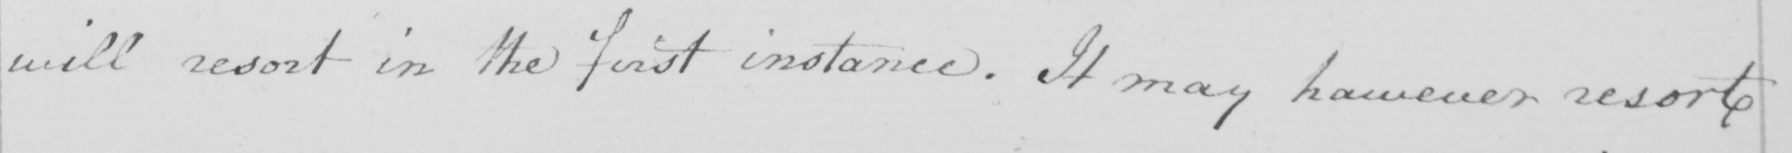Can you read and transcribe this handwriting? will resort in the first instance. It may however resort 